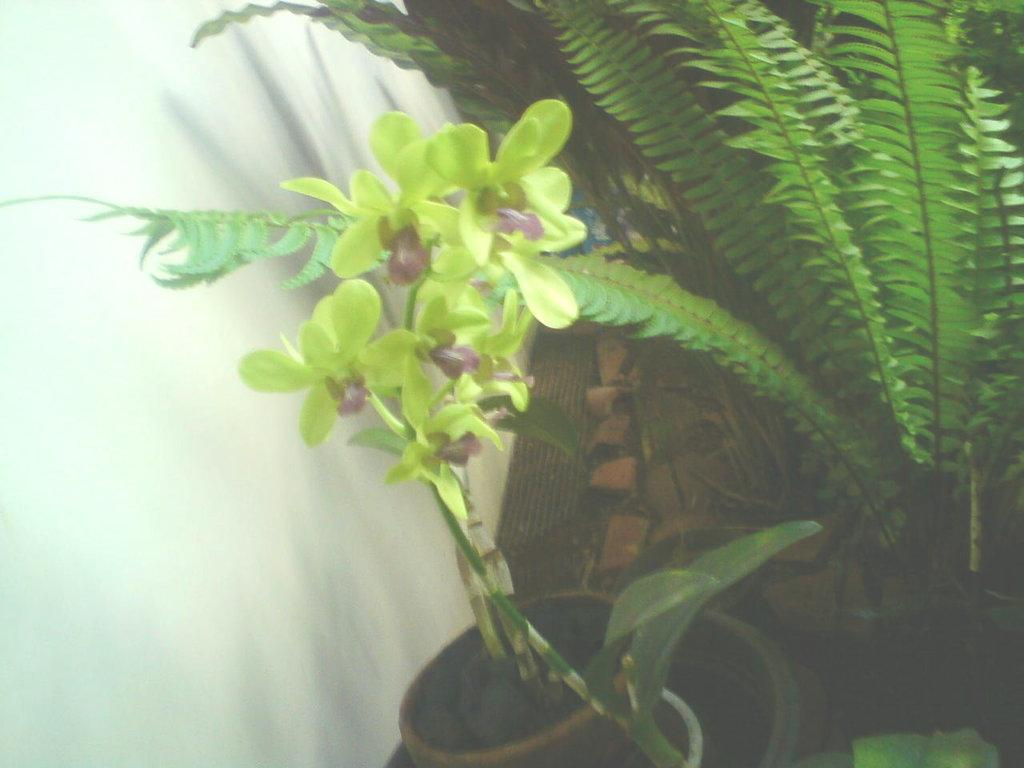Where was the image taken? The image was taken outdoors. What can be seen on the left side of the image? There is a wall on the left side of the image. What type of vegetation is present in the image? There are plants in pots on the right side of the image. What type of wine is being served in the image? There is no wine present in the image. What team is visible in the image? There is no team present in the image. 